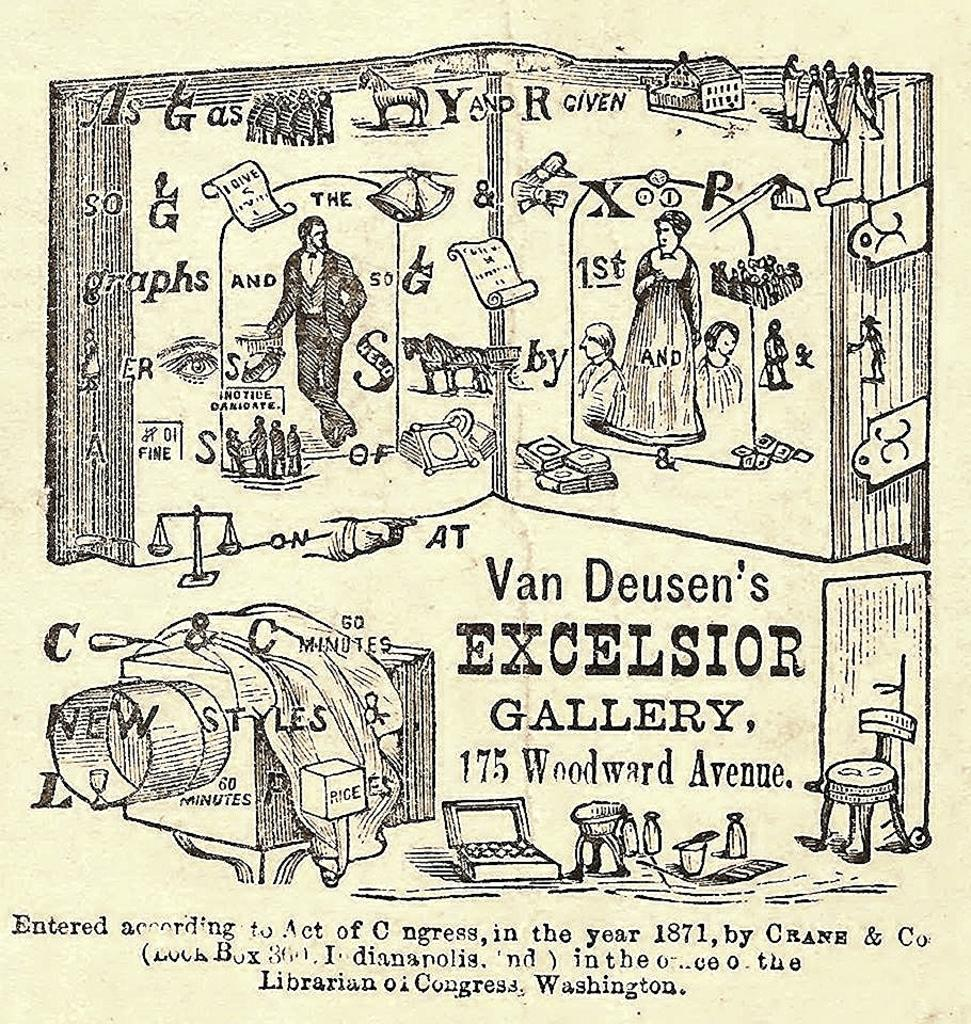What type of visual is the image? The image appears to be a poster. What can be found on the poster? There is text on the poster. Who or what is depicted on the poster? There are people depicted on the poster. What else can be seen in the image besides the people? Bottles and various objects are visible in the image. What color is the yarn used by the people in the image? There is no yarn present in the image, so it is not possible to determine its color. 